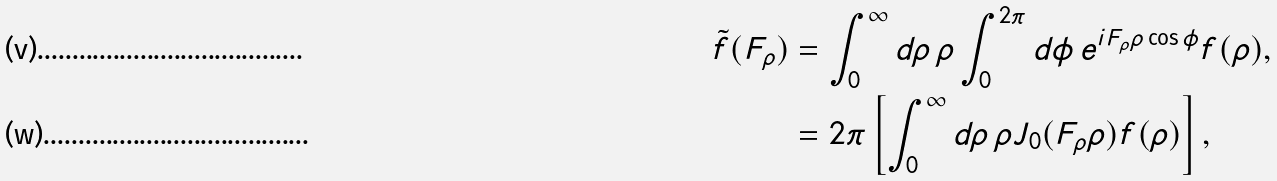<formula> <loc_0><loc_0><loc_500><loc_500>\tilde { f } ( F _ { \rho } ) & = \int _ { 0 } ^ { \infty } d \rho \, \rho \int _ { 0 } ^ { 2 \pi } d \phi \, e ^ { i F _ { \rho } \rho \cos \phi } f ( \rho ) , \\ & = 2 \pi \left [ \int _ { 0 } ^ { \infty } d \rho \, \rho J _ { 0 } ( F _ { \rho } \rho ) f ( \rho ) \right ] ,</formula> 